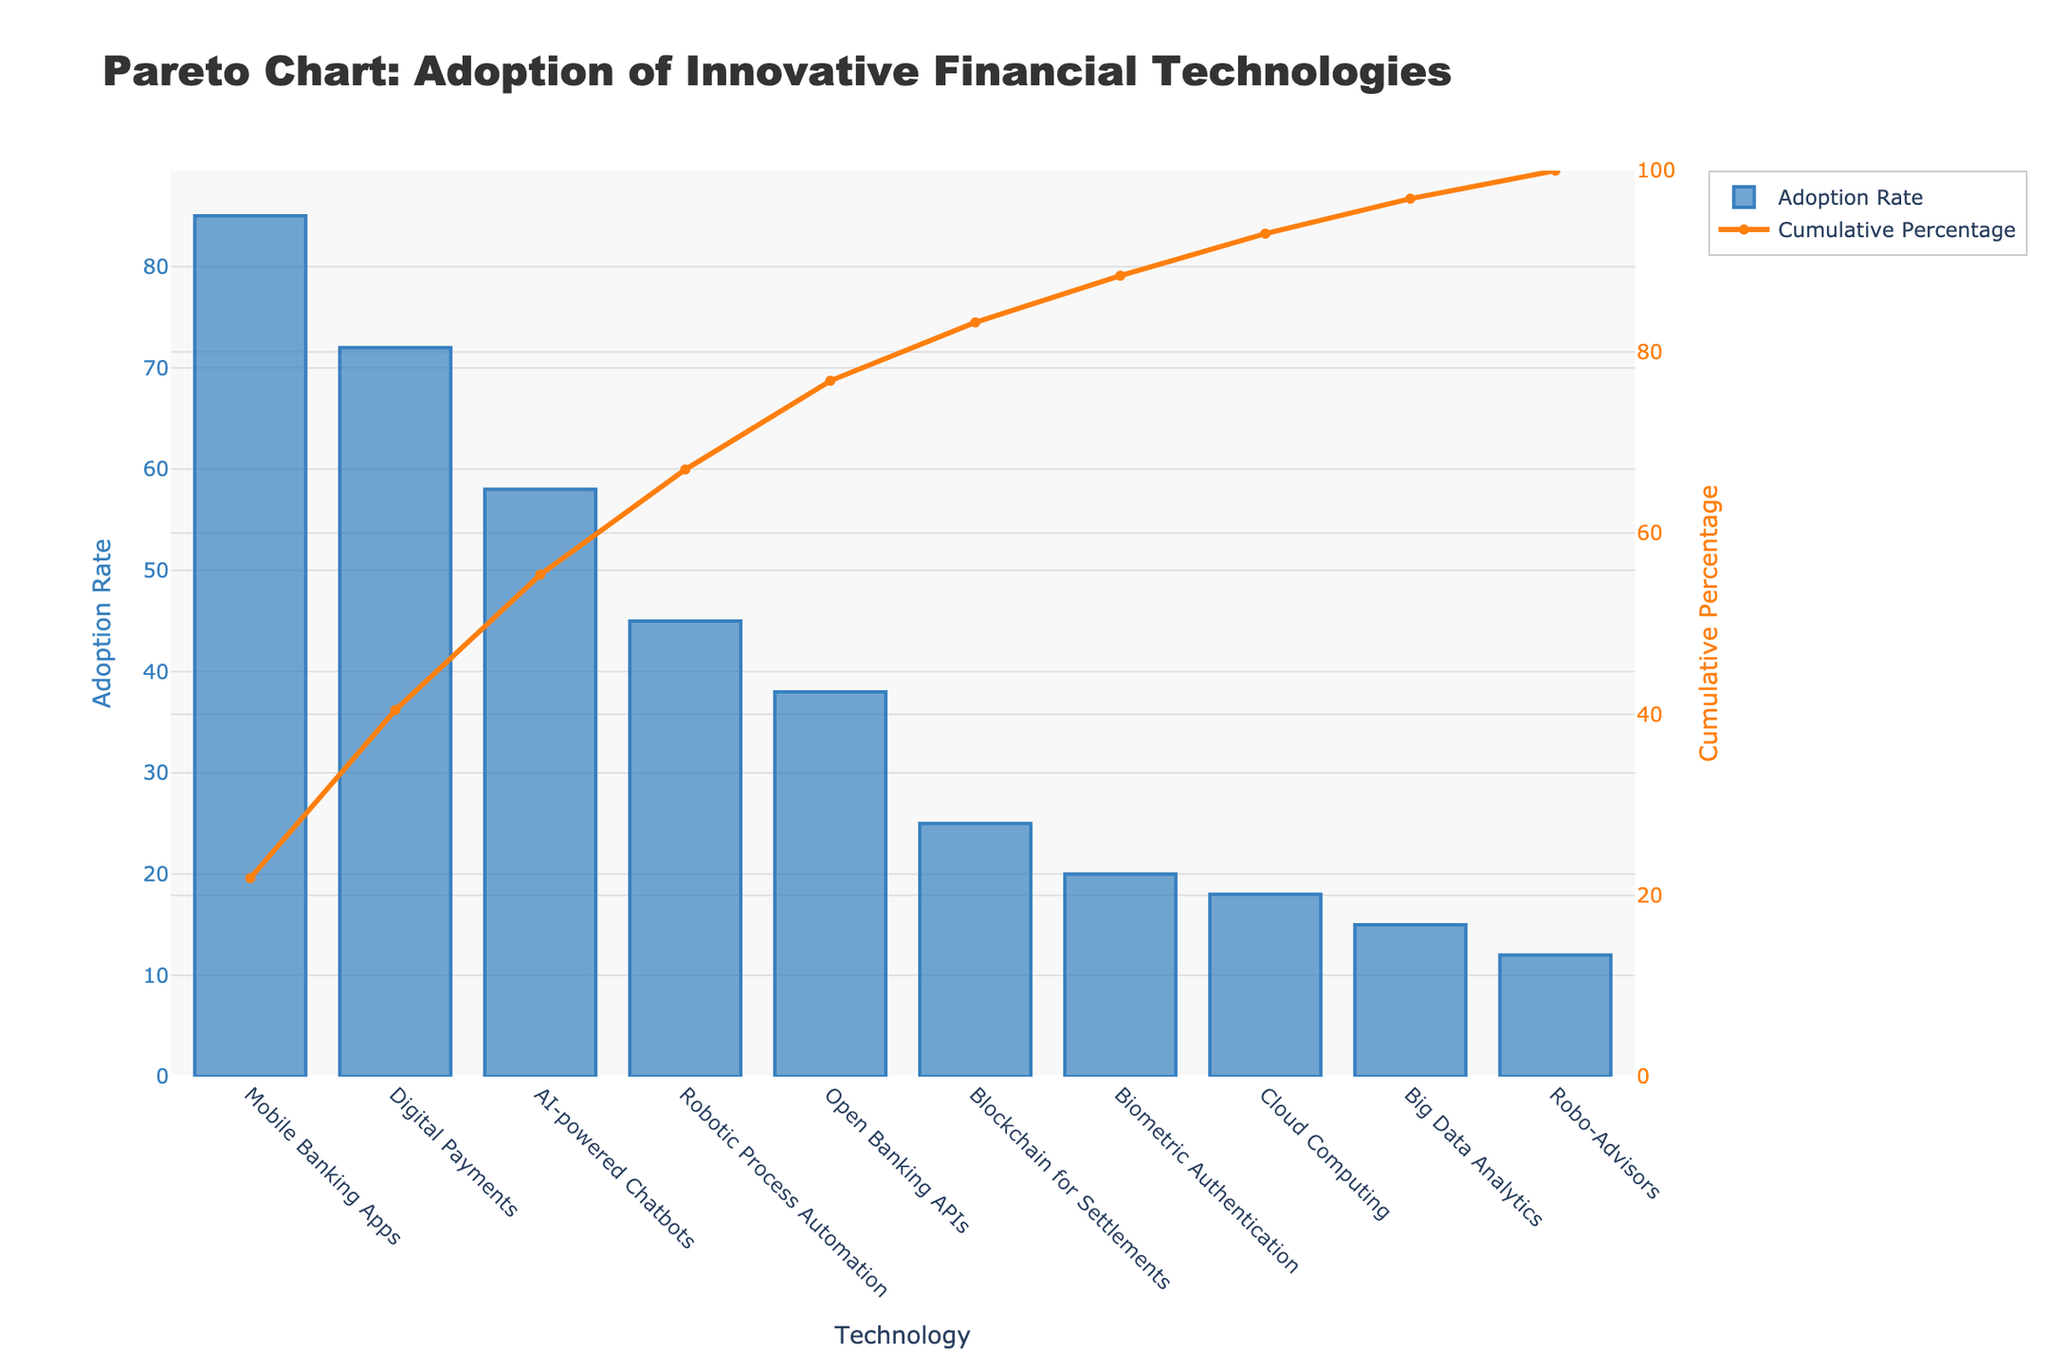What is the title of the figure? The title of the figure is displayed at the top of the chart. It is usually a brief description of what the chart represents.
Answer: Pareto Chart: Adoption of Innovative Financial Technologies Which technology has the highest adoption rate? The highest adoption rate can be identified by looking at the tallest bar in the bar chart.
Answer: Mobile Banking Apps Adoption rates sum to 260, Total adoption = (85+72+58+45+38+25+20+18+15+12) = 388 Robotic Process Automation has reached the 80% cumulative percentage.
Answer: 45 How many technologies have an adoption rate greater than 50%? Count the bars that exceed the 50% mark on the primary y-axis (Adoption Rate). The technologies that have an adoption rate greater than 50% are Mobile Banking Apps, Digital Payments, and AI-powered Chatbots.
Answer: 3 85 + 72 + 58 + 45 = 260, 
Total adoption = 85 + 72 + 58 + 45 + 38 + 25 + 20 + 18 + 15 + 12 = 388, 
Cumulative percentage = (260/388) * 100 (260/388) * 100 ≈ 66.84%
Answer: 66.84% 25 + 20 + 18 + 15 + 12 = 90, 
Total adoption = 85 + 72 + 58 + 45 + 38 + 25 + 20 + 18 + 15 + 12 = 388, 
Cumulative percentage = (90/388) * 100 ≈ 23.20% (90/388) * 100 ≈ 23.20%
Answer: 23.20% 